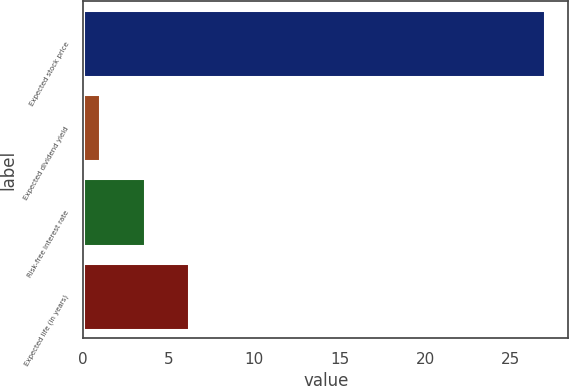<chart> <loc_0><loc_0><loc_500><loc_500><bar_chart><fcel>Expected stock price<fcel>Expected dividend yield<fcel>Risk-free interest rate<fcel>Expected life (in years)<nl><fcel>27<fcel>1<fcel>3.6<fcel>6.2<nl></chart> 